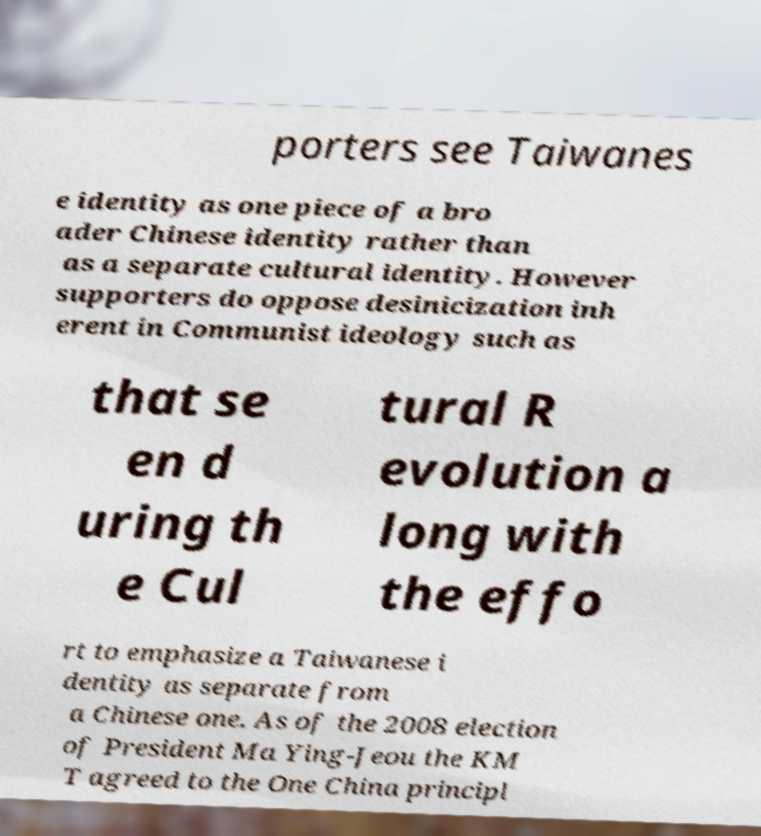I need the written content from this picture converted into text. Can you do that? porters see Taiwanes e identity as one piece of a bro ader Chinese identity rather than as a separate cultural identity. However supporters do oppose desinicization inh erent in Communist ideology such as that se en d uring th e Cul tural R evolution a long with the effo rt to emphasize a Taiwanese i dentity as separate from a Chinese one. As of the 2008 election of President Ma Ying-Jeou the KM T agreed to the One China principl 